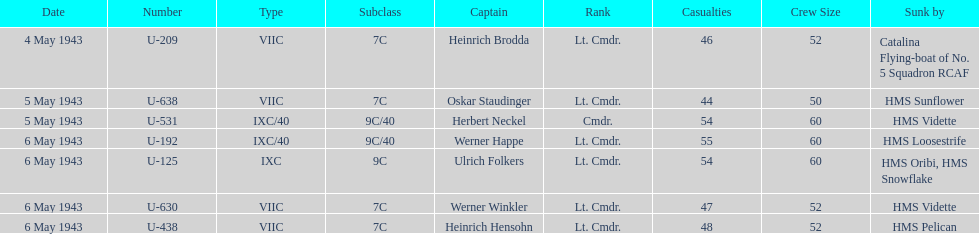How many captains are listed? 7. 